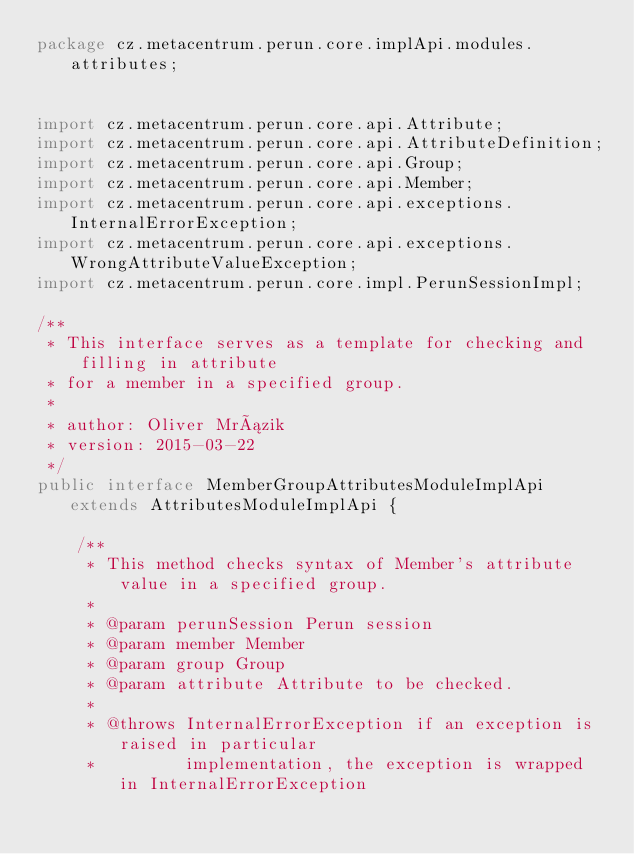<code> <loc_0><loc_0><loc_500><loc_500><_Java_>package cz.metacentrum.perun.core.implApi.modules.attributes;


import cz.metacentrum.perun.core.api.Attribute;
import cz.metacentrum.perun.core.api.AttributeDefinition;
import cz.metacentrum.perun.core.api.Group;
import cz.metacentrum.perun.core.api.Member;
import cz.metacentrum.perun.core.api.exceptions.InternalErrorException;
import cz.metacentrum.perun.core.api.exceptions.WrongAttributeValueException;
import cz.metacentrum.perun.core.impl.PerunSessionImpl;

/**
 * This interface serves as a template for checking and filling in attribute
 * for a member in a specified group.
 *
 * author: Oliver Mrázik
 * version: 2015-03-22
 */
public interface MemberGroupAttributesModuleImplApi extends AttributesModuleImplApi {

	/**
	 * This method checks syntax of Member's attribute value in a specified group.
	 *
	 * @param perunSession Perun session
	 * @param member Member
	 * @param group Group
	 * @param attribute Attribute to be checked.
	 *
	 * @throws InternalErrorException if an exception is raised in particular
	 *         implementation, the exception is wrapped in InternalErrorException</code> 